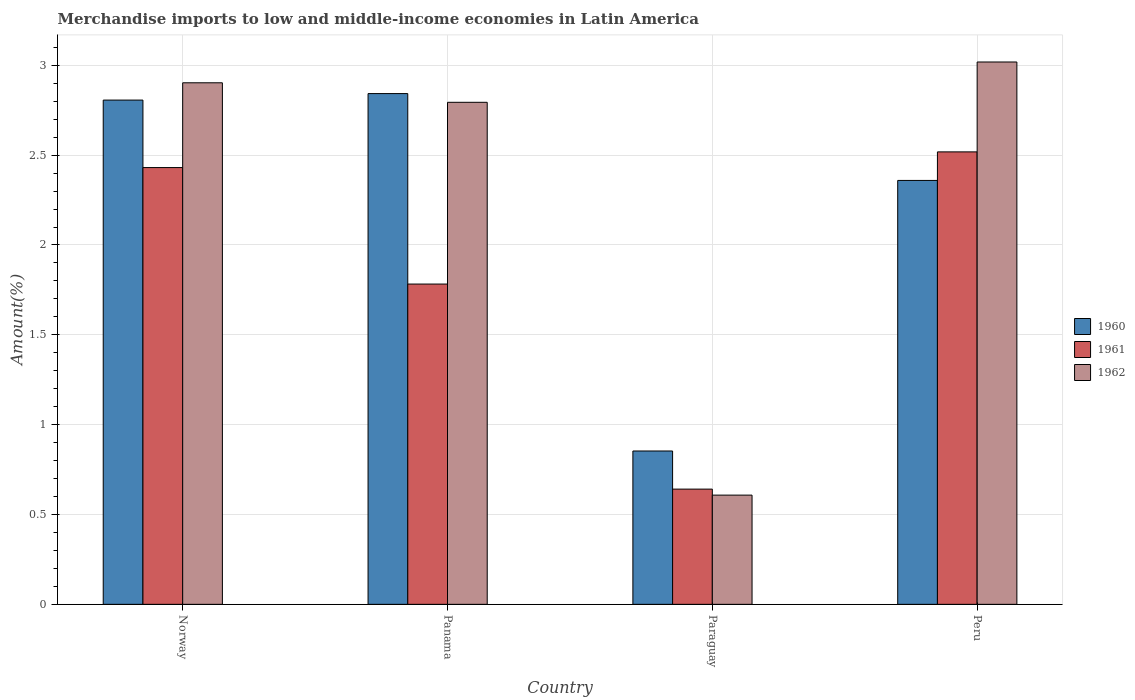How many groups of bars are there?
Your answer should be compact. 4. Are the number of bars per tick equal to the number of legend labels?
Your response must be concise. Yes. Are the number of bars on each tick of the X-axis equal?
Offer a terse response. Yes. How many bars are there on the 3rd tick from the right?
Keep it short and to the point. 3. What is the label of the 3rd group of bars from the left?
Offer a very short reply. Paraguay. In how many cases, is the number of bars for a given country not equal to the number of legend labels?
Your response must be concise. 0. What is the percentage of amount earned from merchandise imports in 1962 in Paraguay?
Your response must be concise. 0.61. Across all countries, what is the maximum percentage of amount earned from merchandise imports in 1961?
Provide a succinct answer. 2.52. Across all countries, what is the minimum percentage of amount earned from merchandise imports in 1961?
Offer a terse response. 0.64. In which country was the percentage of amount earned from merchandise imports in 1960 maximum?
Keep it short and to the point. Panama. In which country was the percentage of amount earned from merchandise imports in 1960 minimum?
Your response must be concise. Paraguay. What is the total percentage of amount earned from merchandise imports in 1961 in the graph?
Your response must be concise. 7.37. What is the difference between the percentage of amount earned from merchandise imports in 1962 in Panama and that in Peru?
Provide a succinct answer. -0.22. What is the difference between the percentage of amount earned from merchandise imports in 1962 in Peru and the percentage of amount earned from merchandise imports in 1960 in Paraguay?
Your response must be concise. 2.17. What is the average percentage of amount earned from merchandise imports in 1961 per country?
Your response must be concise. 1.84. What is the difference between the percentage of amount earned from merchandise imports of/in 1960 and percentage of amount earned from merchandise imports of/in 1961 in Panama?
Ensure brevity in your answer.  1.06. In how many countries, is the percentage of amount earned from merchandise imports in 1960 greater than 2 %?
Ensure brevity in your answer.  3. What is the ratio of the percentage of amount earned from merchandise imports in 1960 in Panama to that in Peru?
Your answer should be compact. 1.2. Is the percentage of amount earned from merchandise imports in 1961 in Paraguay less than that in Peru?
Offer a terse response. Yes. Is the difference between the percentage of amount earned from merchandise imports in 1960 in Norway and Peru greater than the difference between the percentage of amount earned from merchandise imports in 1961 in Norway and Peru?
Ensure brevity in your answer.  Yes. What is the difference between the highest and the second highest percentage of amount earned from merchandise imports in 1961?
Your answer should be very brief. -0.74. What is the difference between the highest and the lowest percentage of amount earned from merchandise imports in 1960?
Your answer should be very brief. 1.99. Is the sum of the percentage of amount earned from merchandise imports in 1961 in Panama and Paraguay greater than the maximum percentage of amount earned from merchandise imports in 1962 across all countries?
Provide a short and direct response. No. What does the 3rd bar from the right in Paraguay represents?
Your answer should be compact. 1960. How many countries are there in the graph?
Ensure brevity in your answer.  4. What is the difference between two consecutive major ticks on the Y-axis?
Ensure brevity in your answer.  0.5. Does the graph contain any zero values?
Make the answer very short. No. What is the title of the graph?
Provide a short and direct response. Merchandise imports to low and middle-income economies in Latin America. Does "1979" appear as one of the legend labels in the graph?
Provide a short and direct response. No. What is the label or title of the Y-axis?
Your answer should be very brief. Amount(%). What is the Amount(%) in 1960 in Norway?
Provide a succinct answer. 2.81. What is the Amount(%) of 1961 in Norway?
Offer a terse response. 2.43. What is the Amount(%) in 1962 in Norway?
Provide a succinct answer. 2.9. What is the Amount(%) in 1960 in Panama?
Your response must be concise. 2.84. What is the Amount(%) of 1961 in Panama?
Your answer should be very brief. 1.78. What is the Amount(%) of 1962 in Panama?
Ensure brevity in your answer.  2.79. What is the Amount(%) in 1960 in Paraguay?
Your answer should be very brief. 0.85. What is the Amount(%) in 1961 in Paraguay?
Give a very brief answer. 0.64. What is the Amount(%) in 1962 in Paraguay?
Your answer should be very brief. 0.61. What is the Amount(%) in 1960 in Peru?
Keep it short and to the point. 2.36. What is the Amount(%) in 1961 in Peru?
Your answer should be compact. 2.52. What is the Amount(%) in 1962 in Peru?
Ensure brevity in your answer.  3.02. Across all countries, what is the maximum Amount(%) of 1960?
Provide a succinct answer. 2.84. Across all countries, what is the maximum Amount(%) in 1961?
Offer a terse response. 2.52. Across all countries, what is the maximum Amount(%) in 1962?
Provide a short and direct response. 3.02. Across all countries, what is the minimum Amount(%) of 1960?
Give a very brief answer. 0.85. Across all countries, what is the minimum Amount(%) in 1961?
Ensure brevity in your answer.  0.64. Across all countries, what is the minimum Amount(%) of 1962?
Make the answer very short. 0.61. What is the total Amount(%) in 1960 in the graph?
Your response must be concise. 8.86. What is the total Amount(%) of 1961 in the graph?
Your answer should be very brief. 7.37. What is the total Amount(%) in 1962 in the graph?
Your answer should be compact. 9.32. What is the difference between the Amount(%) in 1960 in Norway and that in Panama?
Offer a terse response. -0.04. What is the difference between the Amount(%) of 1961 in Norway and that in Panama?
Provide a short and direct response. 0.65. What is the difference between the Amount(%) of 1962 in Norway and that in Panama?
Ensure brevity in your answer.  0.11. What is the difference between the Amount(%) in 1960 in Norway and that in Paraguay?
Offer a very short reply. 1.95. What is the difference between the Amount(%) of 1961 in Norway and that in Paraguay?
Your answer should be compact. 1.79. What is the difference between the Amount(%) in 1962 in Norway and that in Paraguay?
Provide a short and direct response. 2.29. What is the difference between the Amount(%) of 1960 in Norway and that in Peru?
Ensure brevity in your answer.  0.45. What is the difference between the Amount(%) of 1961 in Norway and that in Peru?
Ensure brevity in your answer.  -0.09. What is the difference between the Amount(%) of 1962 in Norway and that in Peru?
Keep it short and to the point. -0.12. What is the difference between the Amount(%) of 1960 in Panama and that in Paraguay?
Give a very brief answer. 1.99. What is the difference between the Amount(%) of 1961 in Panama and that in Paraguay?
Keep it short and to the point. 1.14. What is the difference between the Amount(%) of 1962 in Panama and that in Paraguay?
Provide a succinct answer. 2.19. What is the difference between the Amount(%) of 1960 in Panama and that in Peru?
Provide a succinct answer. 0.48. What is the difference between the Amount(%) of 1961 in Panama and that in Peru?
Your response must be concise. -0.74. What is the difference between the Amount(%) in 1962 in Panama and that in Peru?
Your answer should be compact. -0.22. What is the difference between the Amount(%) in 1960 in Paraguay and that in Peru?
Provide a short and direct response. -1.51. What is the difference between the Amount(%) in 1961 in Paraguay and that in Peru?
Offer a very short reply. -1.88. What is the difference between the Amount(%) of 1962 in Paraguay and that in Peru?
Your answer should be very brief. -2.41. What is the difference between the Amount(%) in 1960 in Norway and the Amount(%) in 1961 in Panama?
Give a very brief answer. 1.02. What is the difference between the Amount(%) in 1960 in Norway and the Amount(%) in 1962 in Panama?
Make the answer very short. 0.01. What is the difference between the Amount(%) of 1961 in Norway and the Amount(%) of 1962 in Panama?
Make the answer very short. -0.36. What is the difference between the Amount(%) of 1960 in Norway and the Amount(%) of 1961 in Paraguay?
Offer a very short reply. 2.17. What is the difference between the Amount(%) of 1960 in Norway and the Amount(%) of 1962 in Paraguay?
Keep it short and to the point. 2.2. What is the difference between the Amount(%) in 1961 in Norway and the Amount(%) in 1962 in Paraguay?
Your answer should be compact. 1.82. What is the difference between the Amount(%) of 1960 in Norway and the Amount(%) of 1961 in Peru?
Your answer should be compact. 0.29. What is the difference between the Amount(%) of 1960 in Norway and the Amount(%) of 1962 in Peru?
Provide a succinct answer. -0.21. What is the difference between the Amount(%) in 1961 in Norway and the Amount(%) in 1962 in Peru?
Your answer should be compact. -0.59. What is the difference between the Amount(%) of 1960 in Panama and the Amount(%) of 1961 in Paraguay?
Provide a succinct answer. 2.2. What is the difference between the Amount(%) of 1960 in Panama and the Amount(%) of 1962 in Paraguay?
Give a very brief answer. 2.23. What is the difference between the Amount(%) of 1961 in Panama and the Amount(%) of 1962 in Paraguay?
Offer a terse response. 1.17. What is the difference between the Amount(%) in 1960 in Panama and the Amount(%) in 1961 in Peru?
Offer a very short reply. 0.32. What is the difference between the Amount(%) in 1960 in Panama and the Amount(%) in 1962 in Peru?
Offer a terse response. -0.18. What is the difference between the Amount(%) in 1961 in Panama and the Amount(%) in 1962 in Peru?
Ensure brevity in your answer.  -1.24. What is the difference between the Amount(%) of 1960 in Paraguay and the Amount(%) of 1961 in Peru?
Your response must be concise. -1.66. What is the difference between the Amount(%) in 1960 in Paraguay and the Amount(%) in 1962 in Peru?
Give a very brief answer. -2.17. What is the difference between the Amount(%) of 1961 in Paraguay and the Amount(%) of 1962 in Peru?
Keep it short and to the point. -2.38. What is the average Amount(%) in 1960 per country?
Your response must be concise. 2.22. What is the average Amount(%) of 1961 per country?
Your answer should be very brief. 1.84. What is the average Amount(%) of 1962 per country?
Give a very brief answer. 2.33. What is the difference between the Amount(%) in 1960 and Amount(%) in 1961 in Norway?
Give a very brief answer. 0.38. What is the difference between the Amount(%) of 1960 and Amount(%) of 1962 in Norway?
Ensure brevity in your answer.  -0.1. What is the difference between the Amount(%) of 1961 and Amount(%) of 1962 in Norway?
Your answer should be very brief. -0.47. What is the difference between the Amount(%) in 1960 and Amount(%) in 1961 in Panama?
Provide a succinct answer. 1.06. What is the difference between the Amount(%) in 1960 and Amount(%) in 1962 in Panama?
Ensure brevity in your answer.  0.05. What is the difference between the Amount(%) of 1961 and Amount(%) of 1962 in Panama?
Your answer should be very brief. -1.01. What is the difference between the Amount(%) of 1960 and Amount(%) of 1961 in Paraguay?
Offer a terse response. 0.21. What is the difference between the Amount(%) in 1960 and Amount(%) in 1962 in Paraguay?
Give a very brief answer. 0.25. What is the difference between the Amount(%) in 1961 and Amount(%) in 1962 in Paraguay?
Keep it short and to the point. 0.03. What is the difference between the Amount(%) in 1960 and Amount(%) in 1961 in Peru?
Ensure brevity in your answer.  -0.16. What is the difference between the Amount(%) in 1960 and Amount(%) in 1962 in Peru?
Ensure brevity in your answer.  -0.66. What is the difference between the Amount(%) in 1961 and Amount(%) in 1962 in Peru?
Your response must be concise. -0.5. What is the ratio of the Amount(%) of 1960 in Norway to that in Panama?
Your answer should be compact. 0.99. What is the ratio of the Amount(%) in 1961 in Norway to that in Panama?
Offer a very short reply. 1.36. What is the ratio of the Amount(%) in 1962 in Norway to that in Panama?
Provide a succinct answer. 1.04. What is the ratio of the Amount(%) of 1960 in Norway to that in Paraguay?
Your response must be concise. 3.29. What is the ratio of the Amount(%) of 1961 in Norway to that in Paraguay?
Provide a short and direct response. 3.79. What is the ratio of the Amount(%) in 1962 in Norway to that in Paraguay?
Your answer should be compact. 4.78. What is the ratio of the Amount(%) of 1960 in Norway to that in Peru?
Keep it short and to the point. 1.19. What is the ratio of the Amount(%) in 1961 in Norway to that in Peru?
Make the answer very short. 0.97. What is the ratio of the Amount(%) in 1962 in Norway to that in Peru?
Your answer should be very brief. 0.96. What is the ratio of the Amount(%) in 1960 in Panama to that in Paraguay?
Your response must be concise. 3.33. What is the ratio of the Amount(%) in 1961 in Panama to that in Paraguay?
Give a very brief answer. 2.78. What is the ratio of the Amount(%) of 1962 in Panama to that in Paraguay?
Your response must be concise. 4.6. What is the ratio of the Amount(%) in 1960 in Panama to that in Peru?
Offer a very short reply. 1.2. What is the ratio of the Amount(%) of 1961 in Panama to that in Peru?
Give a very brief answer. 0.71. What is the ratio of the Amount(%) in 1962 in Panama to that in Peru?
Keep it short and to the point. 0.93. What is the ratio of the Amount(%) of 1960 in Paraguay to that in Peru?
Provide a short and direct response. 0.36. What is the ratio of the Amount(%) in 1961 in Paraguay to that in Peru?
Your answer should be compact. 0.25. What is the ratio of the Amount(%) of 1962 in Paraguay to that in Peru?
Give a very brief answer. 0.2. What is the difference between the highest and the second highest Amount(%) of 1960?
Provide a succinct answer. 0.04. What is the difference between the highest and the second highest Amount(%) in 1961?
Provide a short and direct response. 0.09. What is the difference between the highest and the second highest Amount(%) in 1962?
Ensure brevity in your answer.  0.12. What is the difference between the highest and the lowest Amount(%) of 1960?
Offer a very short reply. 1.99. What is the difference between the highest and the lowest Amount(%) in 1961?
Your answer should be very brief. 1.88. What is the difference between the highest and the lowest Amount(%) in 1962?
Your answer should be compact. 2.41. 